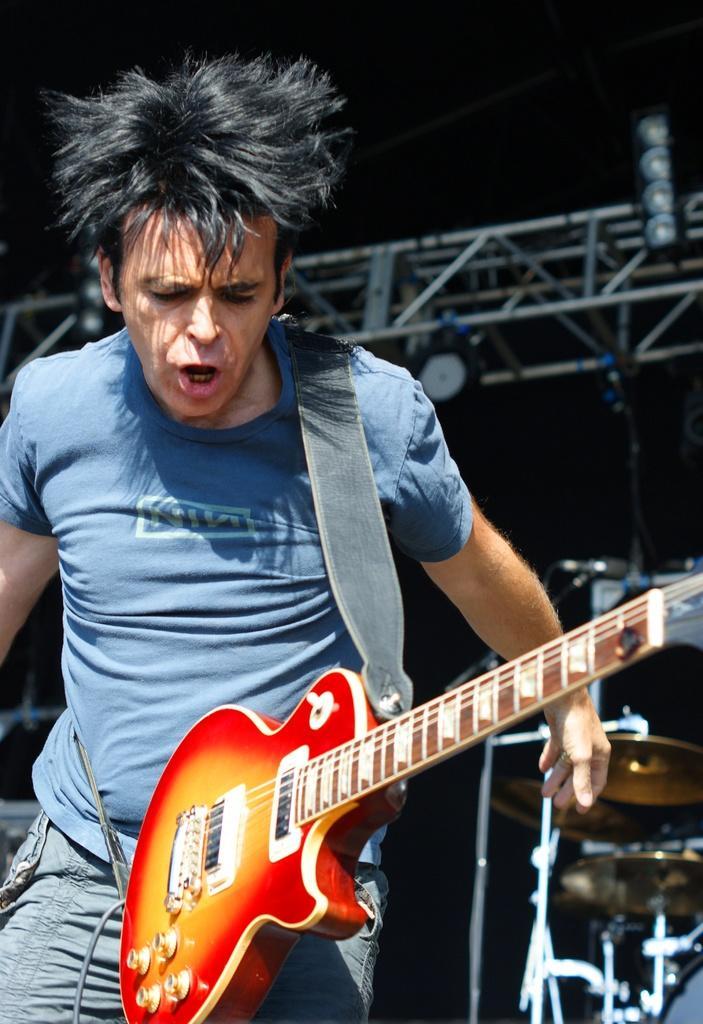Could you give a brief overview of what you see in this image? Here a man is holding a guitar and singing a song with his mouth. He is wearing a T-shirt. 